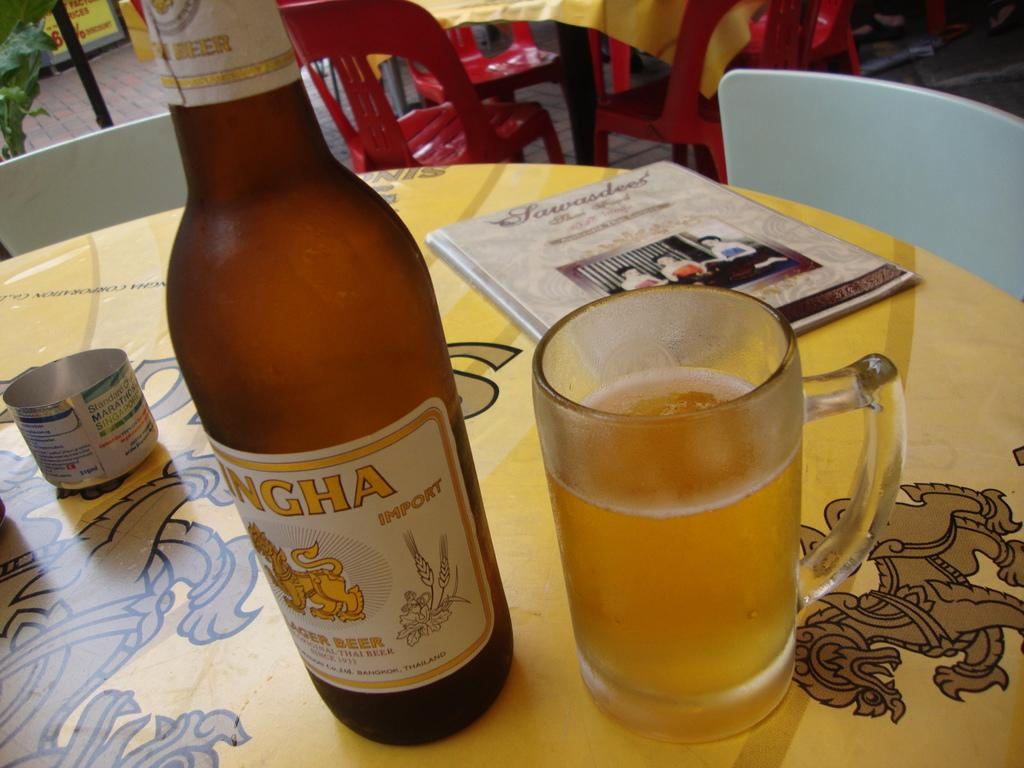What is one of the objects on the table in the image? There is a bottle on the table in the image. What else can be seen on the table? There is a glass on the table in the image. What is the third object on the table? There is a book on the table in the image. What type of furniture is present in the image? There are chairs in the image. Is there any greenery visible in the image? Yes, there is a plant in the image. Can you see a boat in the image? No, there is no boat present in the image. Is the sun visible in the image? No, the sun is not visible in the image. 